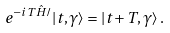Convert formula to latex. <formula><loc_0><loc_0><loc_500><loc_500>e ^ { - i T \hat { H } / } | t , \gamma \rangle = | t + T , \gamma \rangle \, .</formula> 